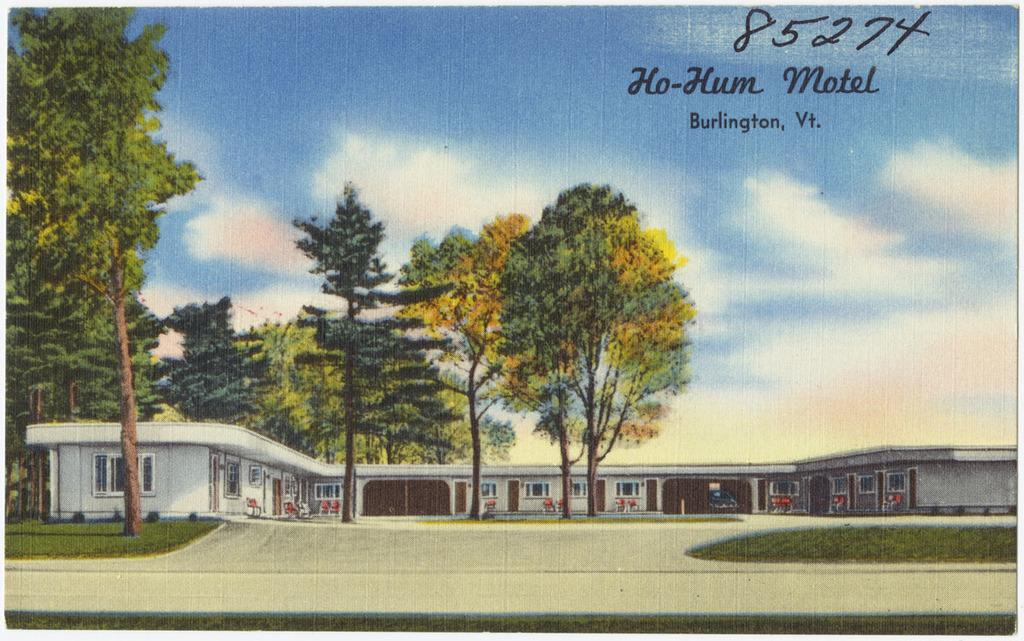<image>
Create a compact narrative representing the image presented. If you have never visited the Ho-Hum Motel in Burlington, Vt, you should. 